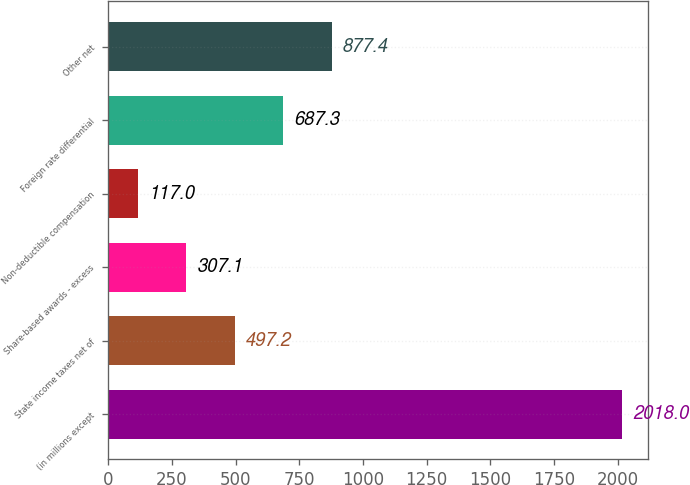Convert chart to OTSL. <chart><loc_0><loc_0><loc_500><loc_500><bar_chart><fcel>(in millions except<fcel>State income taxes net of<fcel>Share-based awards - excess<fcel>Non-deductible compensation<fcel>Foreign rate differential<fcel>Other net<nl><fcel>2018<fcel>497.2<fcel>307.1<fcel>117<fcel>687.3<fcel>877.4<nl></chart> 